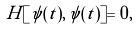<formula> <loc_0><loc_0><loc_500><loc_500>H [ \psi ( t ) , \, \psi ( t ) ] = 0 ,</formula> 